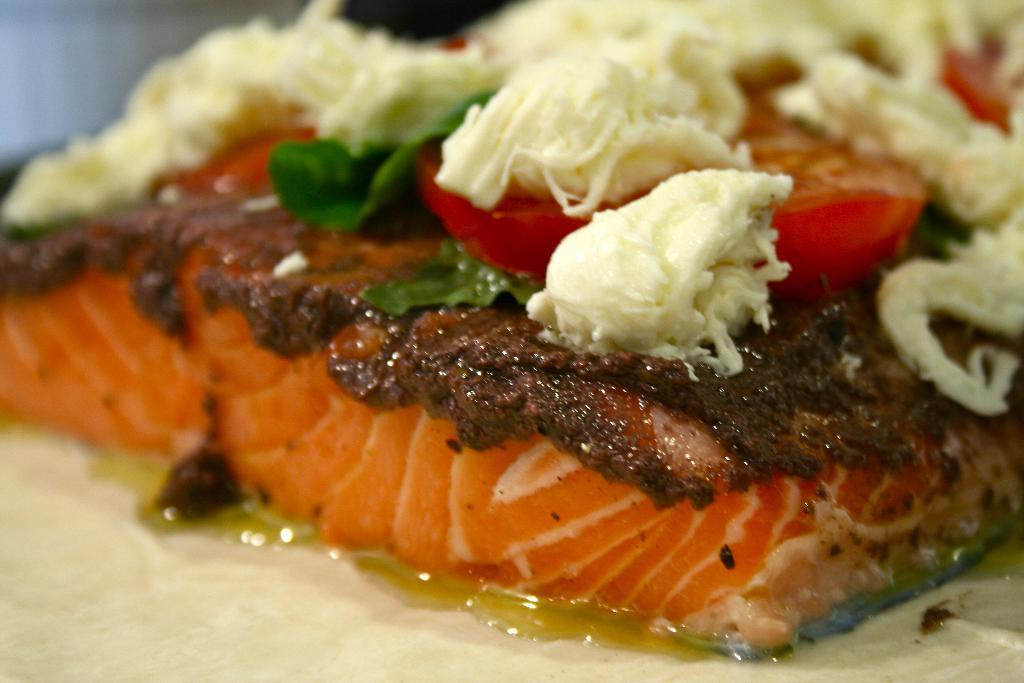What is on the plate in the image? There is food on a plate in the image. How many cacti are present in the image? There are no cacti present in the image; it only features a plate with food on it. What things can be seen in the image besides the food on the plate? The provided facts do not mention any other items in the image besides the food on the plate, so we cannot answer this question definitively. 